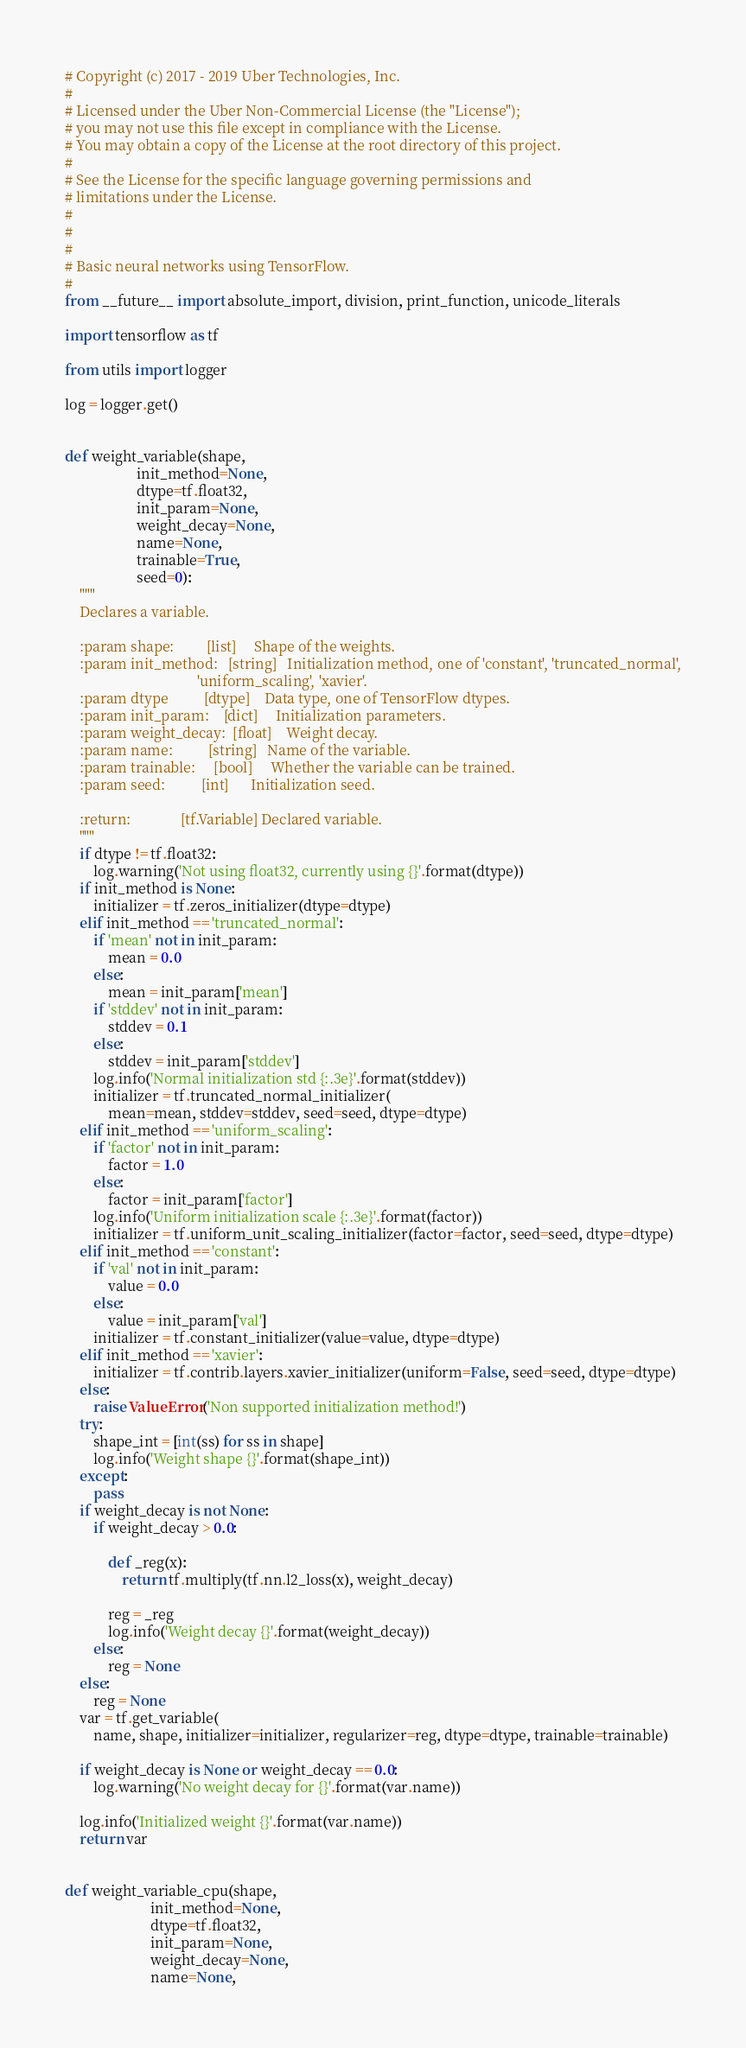Convert code to text. <code><loc_0><loc_0><loc_500><loc_500><_Python_># Copyright (c) 2017 - 2019 Uber Technologies, Inc.
#
# Licensed under the Uber Non-Commercial License (the "License");
# you may not use this file except in compliance with the License.
# You may obtain a copy of the License at the root directory of this project.
#
# See the License for the specific language governing permissions and
# limitations under the License.
#
#
#
# Basic neural networks using TensorFlow.
#
from __future__ import absolute_import, division, print_function, unicode_literals

import tensorflow as tf

from utils import logger

log = logger.get()


def weight_variable(shape,
                    init_method=None,
                    dtype=tf.float32,
                    init_param=None,
                    weight_decay=None,
                    name=None,
                    trainable=True,
                    seed=0):
    """
    Declares a variable.

    :param shape:         [list]     Shape of the weights.
    :param init_method:   [string]   Initialization method, one of 'constant', 'truncated_normal',
                                     'uniform_scaling', 'xavier'.
    :param dtype          [dtype]    Data type, one of TensorFlow dtypes.
    :param init_param:    [dict]     Initialization parameters.
    :param weight_decay:  [float]    Weight decay.
    :param name:          [string]   Name of the variable.
    :param trainable:     [bool]     Whether the variable can be trained.
    :param seed:          [int]      Initialization seed.

    :return:              [tf.Variable] Declared variable.
    """
    if dtype != tf.float32:
        log.warning('Not using float32, currently using {}'.format(dtype))
    if init_method is None:
        initializer = tf.zeros_initializer(dtype=dtype)
    elif init_method == 'truncated_normal':
        if 'mean' not in init_param:
            mean = 0.0
        else:
            mean = init_param['mean']
        if 'stddev' not in init_param:
            stddev = 0.1
        else:
            stddev = init_param['stddev']
        log.info('Normal initialization std {:.3e}'.format(stddev))
        initializer = tf.truncated_normal_initializer(
            mean=mean, stddev=stddev, seed=seed, dtype=dtype)
    elif init_method == 'uniform_scaling':
        if 'factor' not in init_param:
            factor = 1.0
        else:
            factor = init_param['factor']
        log.info('Uniform initialization scale {:.3e}'.format(factor))
        initializer = tf.uniform_unit_scaling_initializer(factor=factor, seed=seed, dtype=dtype)
    elif init_method == 'constant':
        if 'val' not in init_param:
            value = 0.0
        else:
            value = init_param['val']
        initializer = tf.constant_initializer(value=value, dtype=dtype)
    elif init_method == 'xavier':
        initializer = tf.contrib.layers.xavier_initializer(uniform=False, seed=seed, dtype=dtype)
    else:
        raise ValueError('Non supported initialization method!')
    try:
        shape_int = [int(ss) for ss in shape]
        log.info('Weight shape {}'.format(shape_int))
    except:
        pass
    if weight_decay is not None:
        if weight_decay > 0.0:

            def _reg(x):
                return tf.multiply(tf.nn.l2_loss(x), weight_decay)

            reg = _reg
            log.info('Weight decay {}'.format(weight_decay))
        else:
            reg = None
    else:
        reg = None
    var = tf.get_variable(
        name, shape, initializer=initializer, regularizer=reg, dtype=dtype, trainable=trainable)

    if weight_decay is None or weight_decay == 0.0:
        log.warning('No weight decay for {}'.format(var.name))

    log.info('Initialized weight {}'.format(var.name))
    return var


def weight_variable_cpu(shape,
                        init_method=None,
                        dtype=tf.float32,
                        init_param=None,
                        weight_decay=None,
                        name=None,</code> 